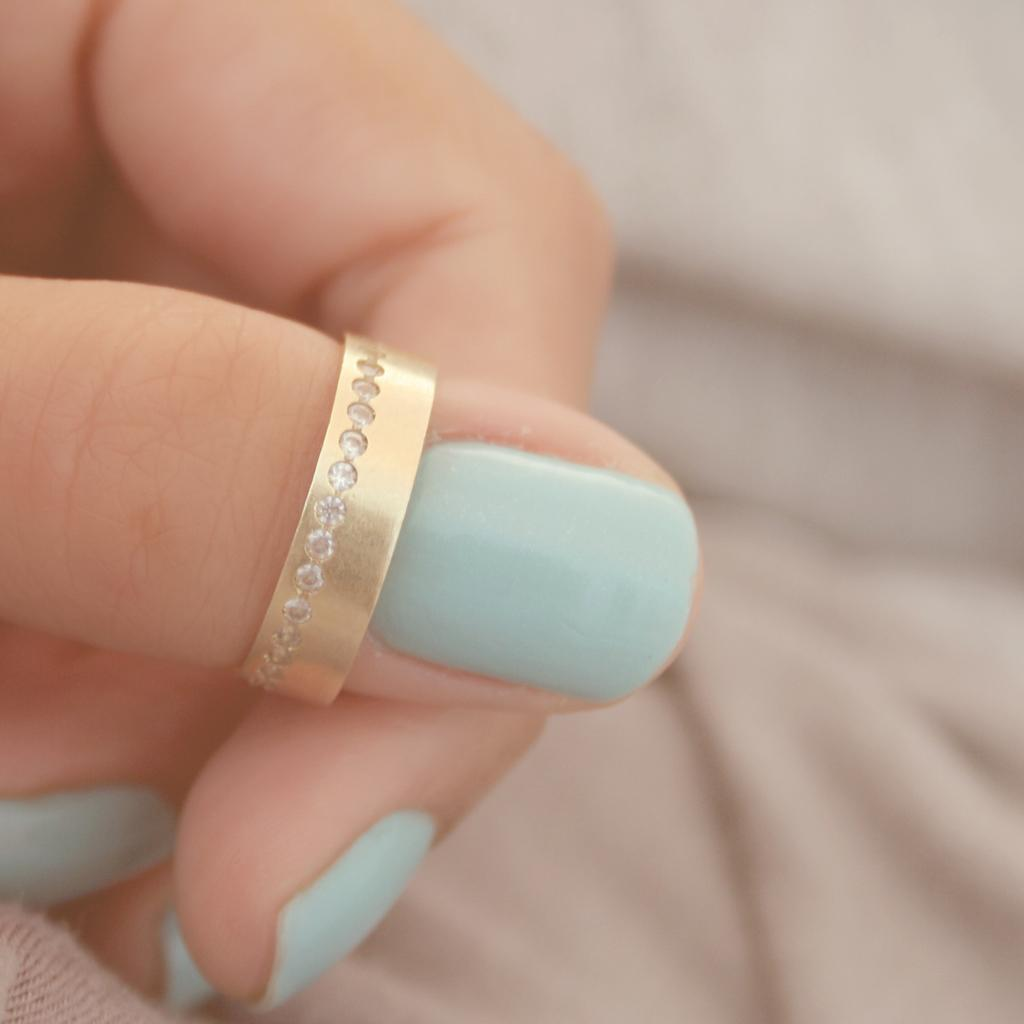What part of a person is visible in the image? There is a hand of a person in the image. What is on the hand in the image? The hand has a ring on it. Can you describe the background of the image? The background of the image is blurred. How many dimes can be seen on the hand in the image? There are no dimes visible on the hand in the image. What type of appliance is being used by the person in the image? There is no appliance visible in the image; only the hand with a ring is present. 